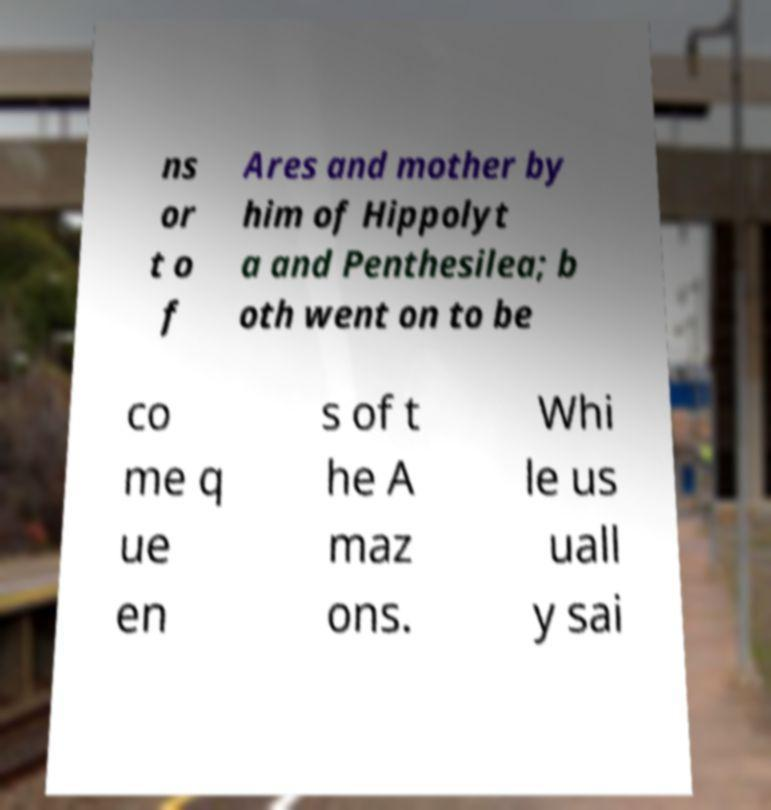Please identify and transcribe the text found in this image. ns or t o f Ares and mother by him of Hippolyt a and Penthesilea; b oth went on to be co me q ue en s of t he A maz ons. Whi le us uall y sai 